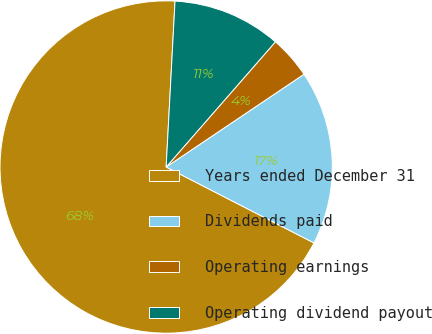Convert chart to OTSL. <chart><loc_0><loc_0><loc_500><loc_500><pie_chart><fcel>Years ended December 31<fcel>Dividends paid<fcel>Operating earnings<fcel>Operating dividend payout<nl><fcel>68.3%<fcel>16.98%<fcel>4.15%<fcel>10.57%<nl></chart> 